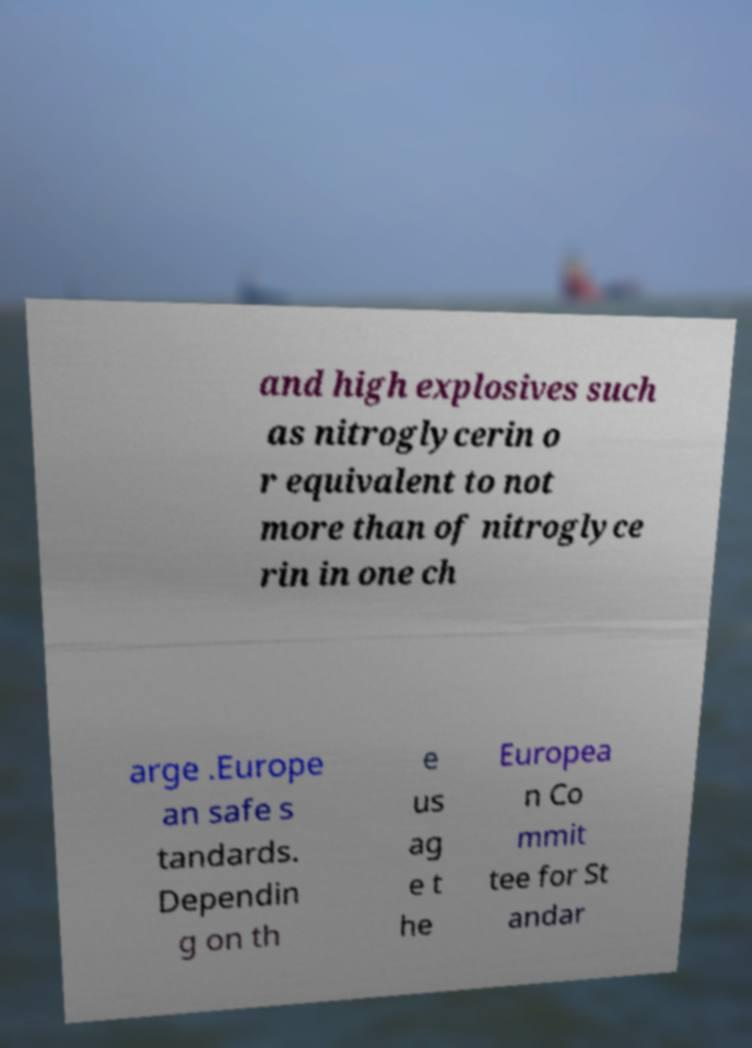Can you read and provide the text displayed in the image?This photo seems to have some interesting text. Can you extract and type it out for me? and high explosives such as nitroglycerin o r equivalent to not more than of nitroglyce rin in one ch arge .Europe an safe s tandards. Dependin g on th e us ag e t he Europea n Co mmit tee for St andar 